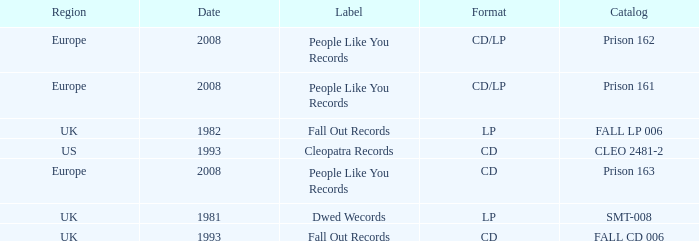Which Label has a Date smaller than 2008, and a Catalog of fall cd 006? Fall Out Records. 